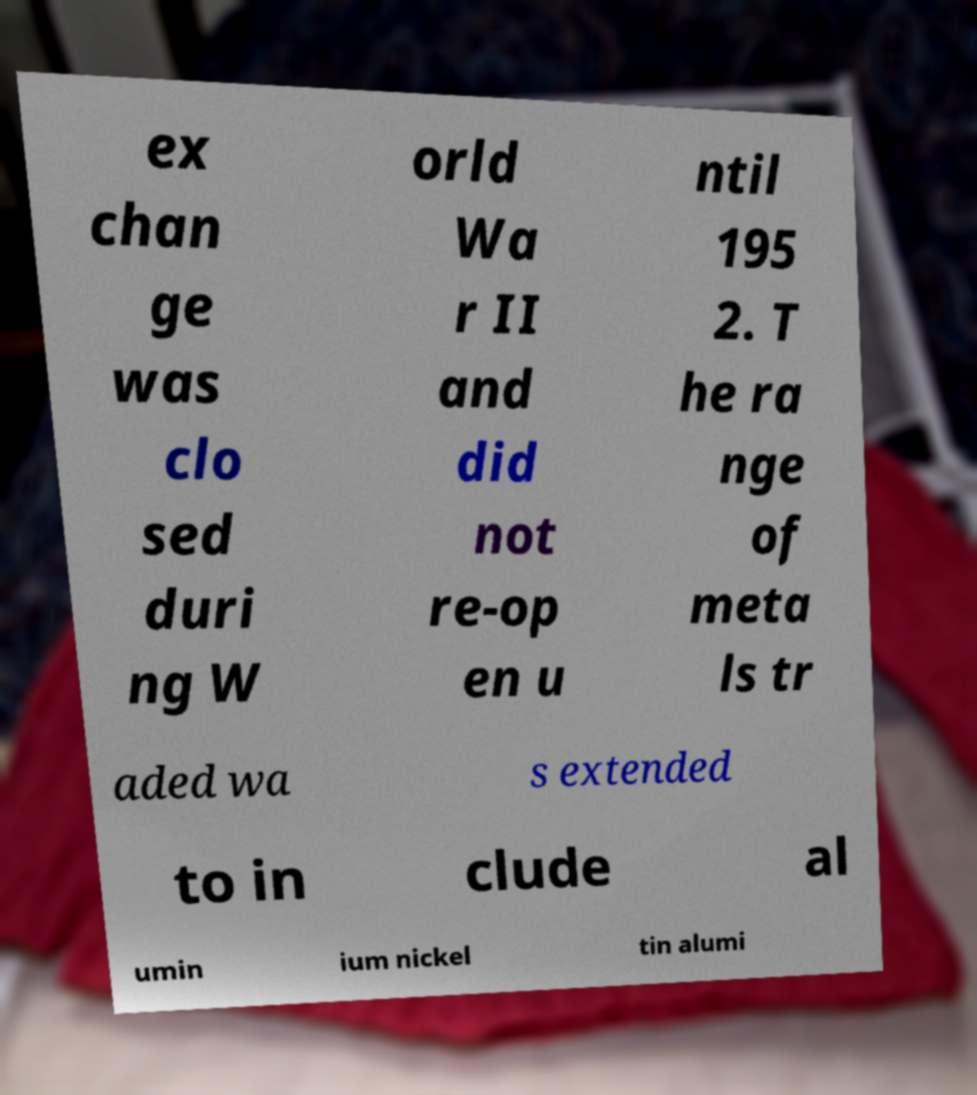Can you read and provide the text displayed in the image?This photo seems to have some interesting text. Can you extract and type it out for me? ex chan ge was clo sed duri ng W orld Wa r II and did not re-op en u ntil 195 2. T he ra nge of meta ls tr aded wa s extended to in clude al umin ium nickel tin alumi 